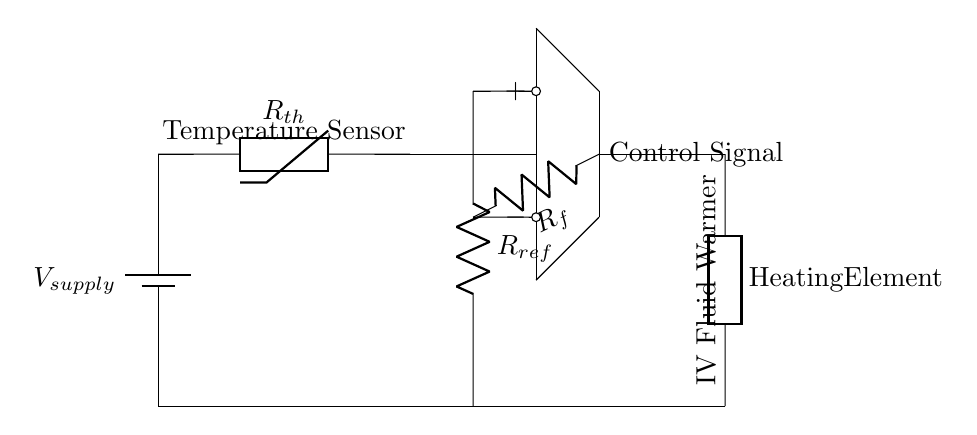What type of component is labeled as Rth in the circuit? Rth is a thermistor, which is a temperature-sensitive resistor used to measure temperature changes.
Answer: thermistor What does Rref represent in the circuit? Rref is a reference resistor that establishes a known reference voltage for comparison with the input from the thermistor, aiding in temperature control.
Answer: reference resistor How many resistors are present in the circuit diagram? There are two resistors shown: Rref and Rf, connected as part of the feedback mechanism in the operational amplifier circuit.
Answer: two What is the output of the operational amplifier connected to? The output of the operational amplifier is connected to a heating element, which is used to warm the IV fluid based on the controlled feedback from the thermistor.
Answer: heating element What is the purpose of the thermistor in this circuit? The thermistor detects the temperature of the fluid and provides input to the operational amplifier to maintain the desired temperature, ensuring effective warming of the IV fluid.
Answer: temperature sensing What is the role of Rf in the circuit? Rf is a feedback resistor that helps determine the gain of the operational amplifier, crucial for controlling the output signal that adjusts the heating element's power.
Answer: feedback resistor Which direction does the current flow from the power supply to the components? The current flows from the positive terminal of the battery through the thermistor and then to the operational amplifier before finally reaching the heating element.
Answer: positive to negative 